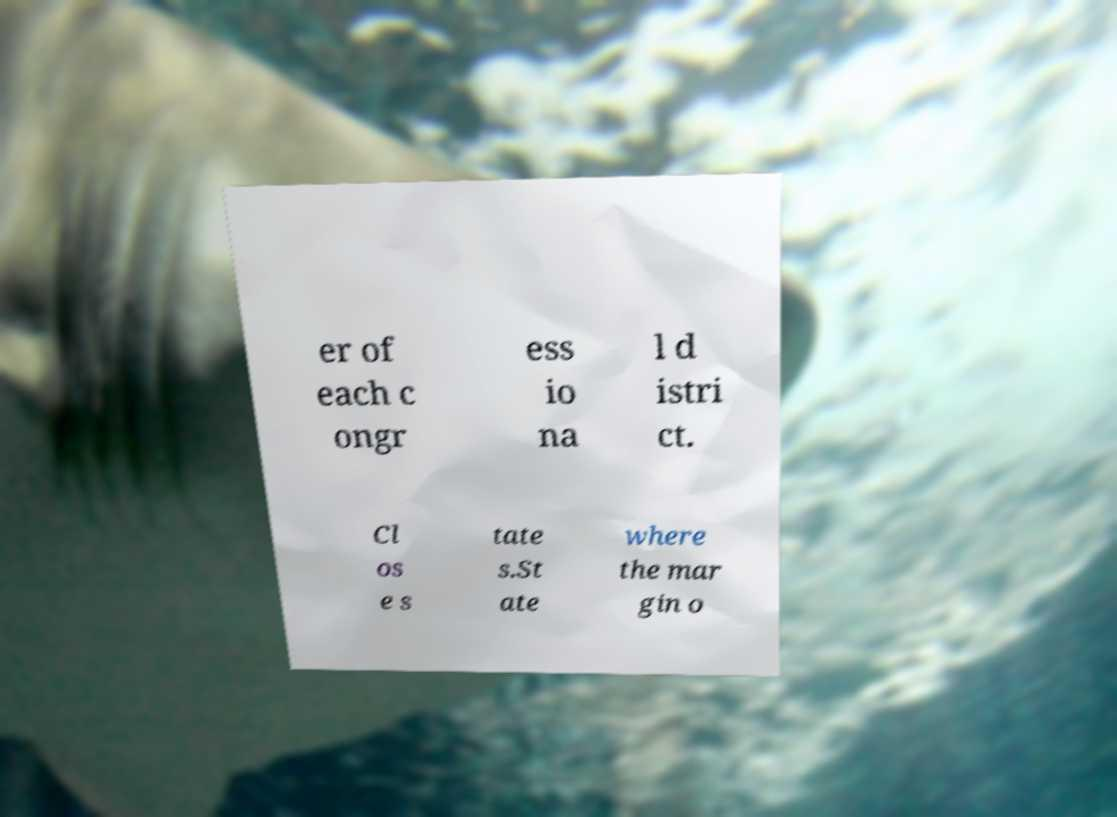Could you assist in decoding the text presented in this image and type it out clearly? er of each c ongr ess io na l d istri ct. Cl os e s tate s.St ate where the mar gin o 